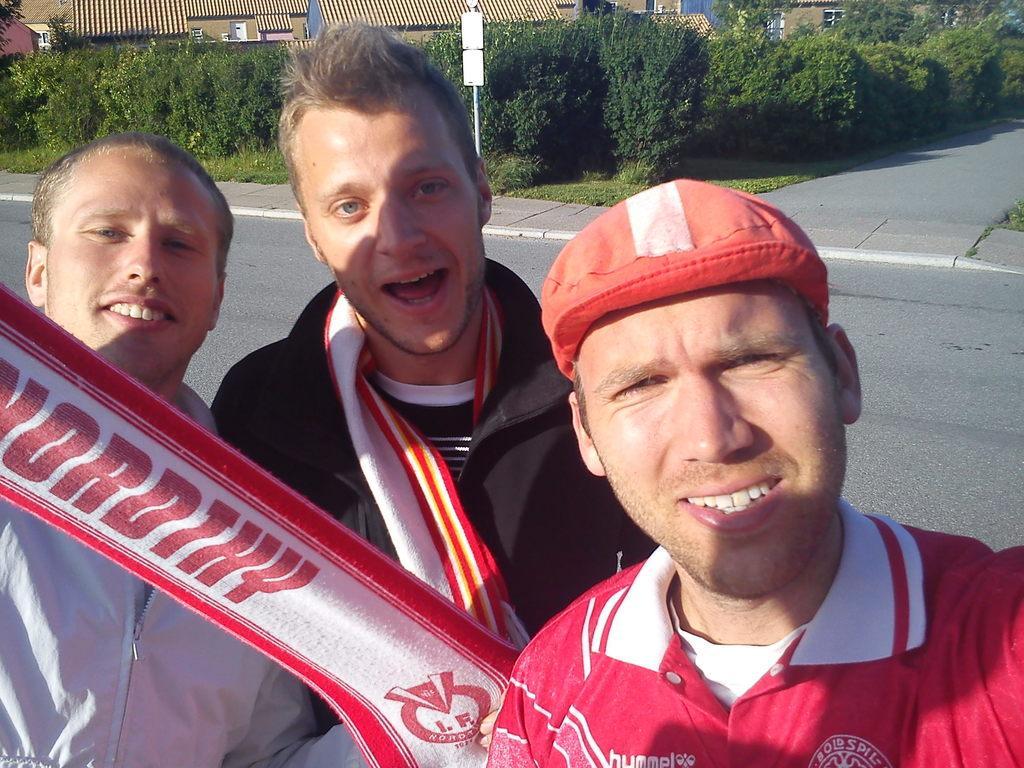Please provide a concise description of this image. In this picture we can see few people are on the road and taking picture, behind we can see some trees and houses. 